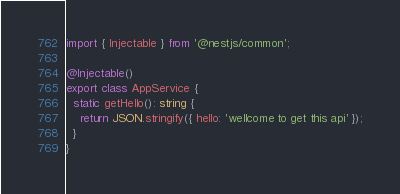Convert code to text. <code><loc_0><loc_0><loc_500><loc_500><_TypeScript_>import { Injectable } from '@nestjs/common';

@Injectable()
export class AppService {
  static getHello(): string {
    return JSON.stringify({ hello: 'wellcome to get this api' });
  }
}
</code> 